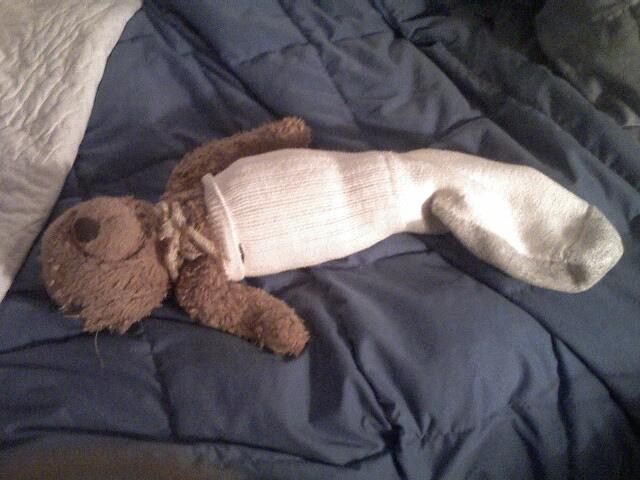Is the teddy bear wearing a dress?
Short answer required. No. Where is the teddy bear laying?
Answer briefly. Bed. How many stuffed animals are there?
Give a very brief answer. 1. What is the bear in?
Keep it brief. Sock. 